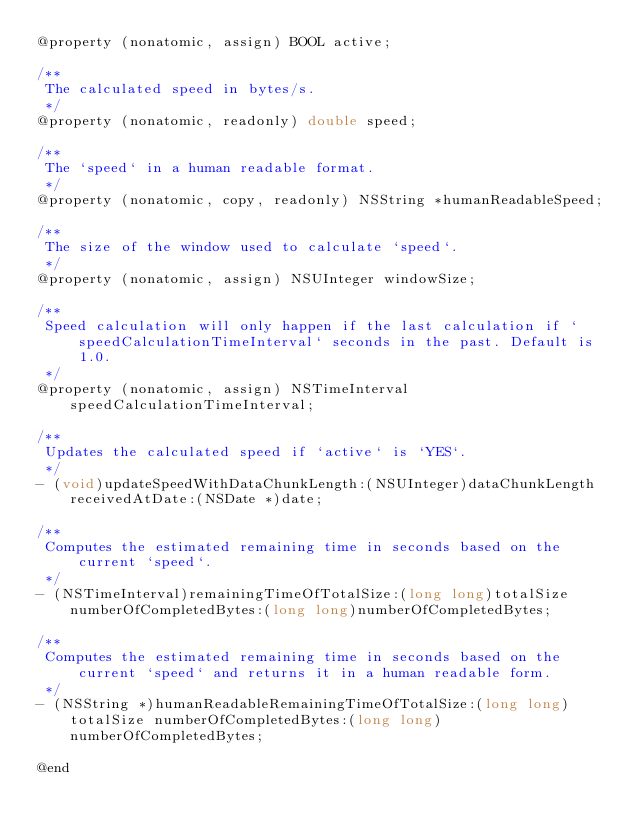Convert code to text. <code><loc_0><loc_0><loc_500><loc_500><_C_>@property (nonatomic, assign) BOOL active;

/**
 The calculated speed in bytes/s.
 */
@property (nonatomic, readonly) double speed;

/**
 The `speed` in a human readable format.
 */
@property (nonatomic, copy, readonly) NSString *humanReadableSpeed;

/**
 The size of the window used to calculate `speed`.
 */
@property (nonatomic, assign) NSUInteger windowSize;

/**
 Speed calculation will only happen if the last calculation if `speedCalculationTimeInterval` seconds in the past. Default is 1.0.
 */
@property (nonatomic, assign) NSTimeInterval speedCalculationTimeInterval;

/**
 Updates the calculated speed if `active` is `YES`.
 */
- (void)updateSpeedWithDataChunkLength:(NSUInteger)dataChunkLength receivedAtDate:(NSDate *)date;

/**
 Computes the estimated remaining time in seconds based on the current `speed`.
 */
- (NSTimeInterval)remainingTimeOfTotalSize:(long long)totalSize numberOfCompletedBytes:(long long)numberOfCompletedBytes;

/**
 Computes the estimated remaining time in seconds based on the current `speed` and returns it in a human readable form.
 */
- (NSString *)humanReadableRemainingTimeOfTotalSize:(long long)totalSize numberOfCompletedBytes:(long long)numberOfCompletedBytes;

@end
</code> 